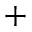<formula> <loc_0><loc_0><loc_500><loc_500>+</formula> 